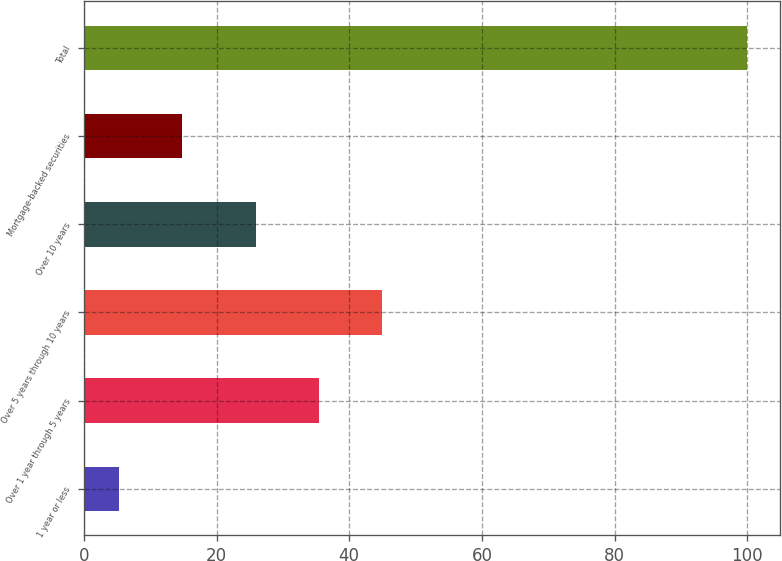Convert chart to OTSL. <chart><loc_0><loc_0><loc_500><loc_500><bar_chart><fcel>1 year or less<fcel>Over 1 year through 5 years<fcel>Over 5 years through 10 years<fcel>Over 10 years<fcel>Mortgage-backed securities<fcel>Total<nl><fcel>5.3<fcel>35.47<fcel>44.94<fcel>26<fcel>14.77<fcel>100<nl></chart> 